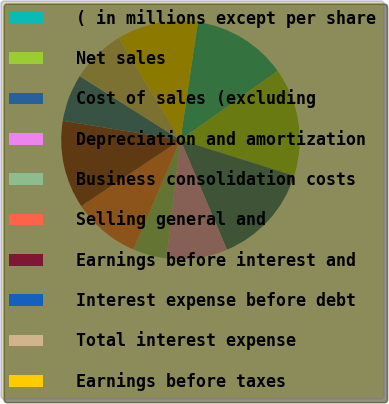Convert chart to OTSL. <chart><loc_0><loc_0><loc_500><loc_500><pie_chart><fcel>( in millions except per share<fcel>Net sales<fcel>Cost of sales (excluding<fcel>Depreciation and amortization<fcel>Business consolidation costs<fcel>Selling general and<fcel>Earnings before interest and<fcel>Interest expense before debt<fcel>Total interest expense<fcel>Earnings before taxes<nl><fcel>12.84%<fcel>14.68%<fcel>13.76%<fcel>8.26%<fcel>4.59%<fcel>9.17%<fcel>11.93%<fcel>6.42%<fcel>7.34%<fcel>11.01%<nl></chart> 